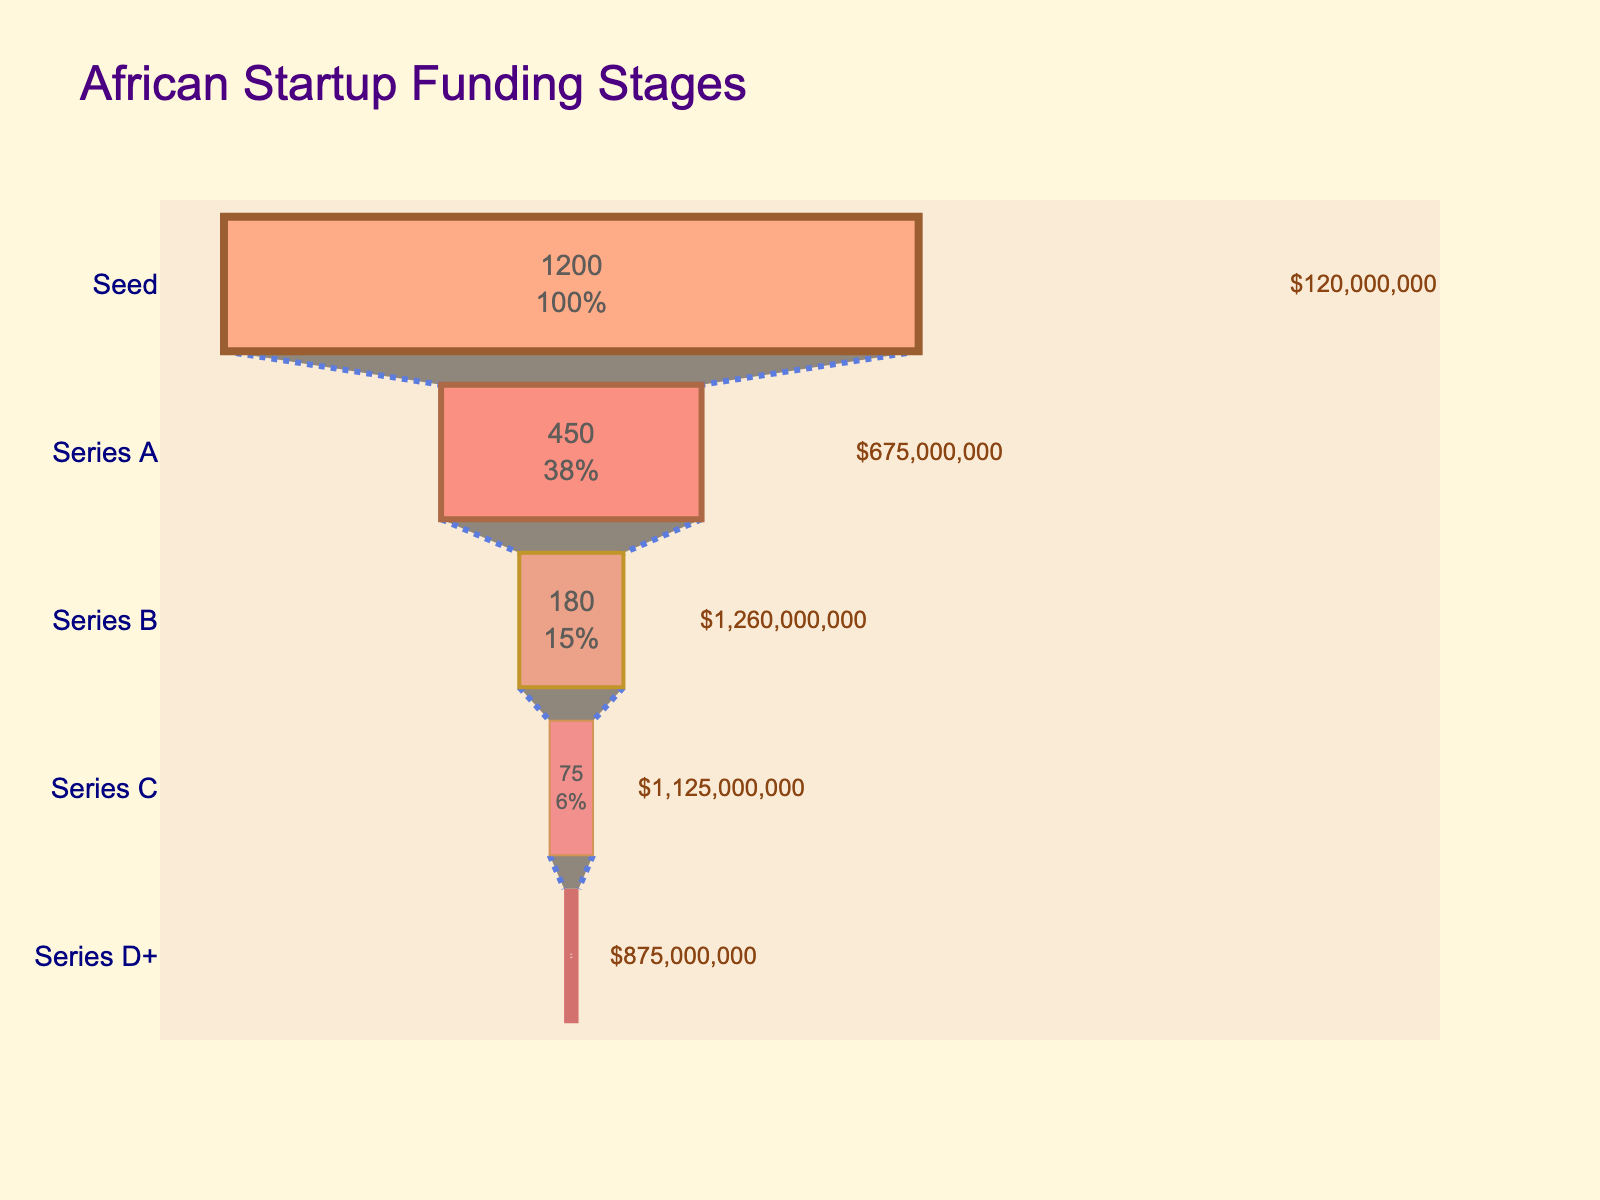How many stages are shown in the funnel chart? Count the number of stages listed on the left side of the funnel chart.
Answer: 5 Which funding stage has the highest number of startups? Identify the stage with the largest segment in the funnel chart.
Answer: Seed What is the total investment for Series C funding? Look at the annotation next to the Series C segment for the total investment amount.
Answer: $1,125,000,000 How does the number of startups in Series A compare to those in Series B? Compare the heights of the Series A and Series B segments in the funnel chart.
Answer: Series A has more startups than Series B What is the color of the Series D+ funding stage? Identify the specific color used for the Series D+ segment in the funnel chart.
Answer: Light brown (around #DEB887) How much total investment has been allocated to startups in Series A and Series B combined? Add the total investment amounts shown for both Series A and Series B.
Answer: $1,935,000,000 What percentage of startups that received Seed funding made it to Series A? Divide the number of startups in Series A by the number of startups in Seed, then multiply by 100 to get the percentage. (450 / 1200) * 100 = 37.5%
Answer: 37.5% Which stage has the smallest number of startups? Identify the stage with the smallest segment in the funnel chart.
Answer: Series D+ How does the total investment for Series B compare to Series D+? Compare the total investment amounts annotated next to Series B and Series D+ segments.
Answer: Series B has more total investment than Series D+ What percentage of the total number of startups are in the Series C stage? Calculate the proportion of startups in Series C by dividing the number of Series C startups by the total number across all stages, then multiply by 100. (75)/(1200 + 450 + 180 + 75 + 25) * 100.
Answer: 3.45% 